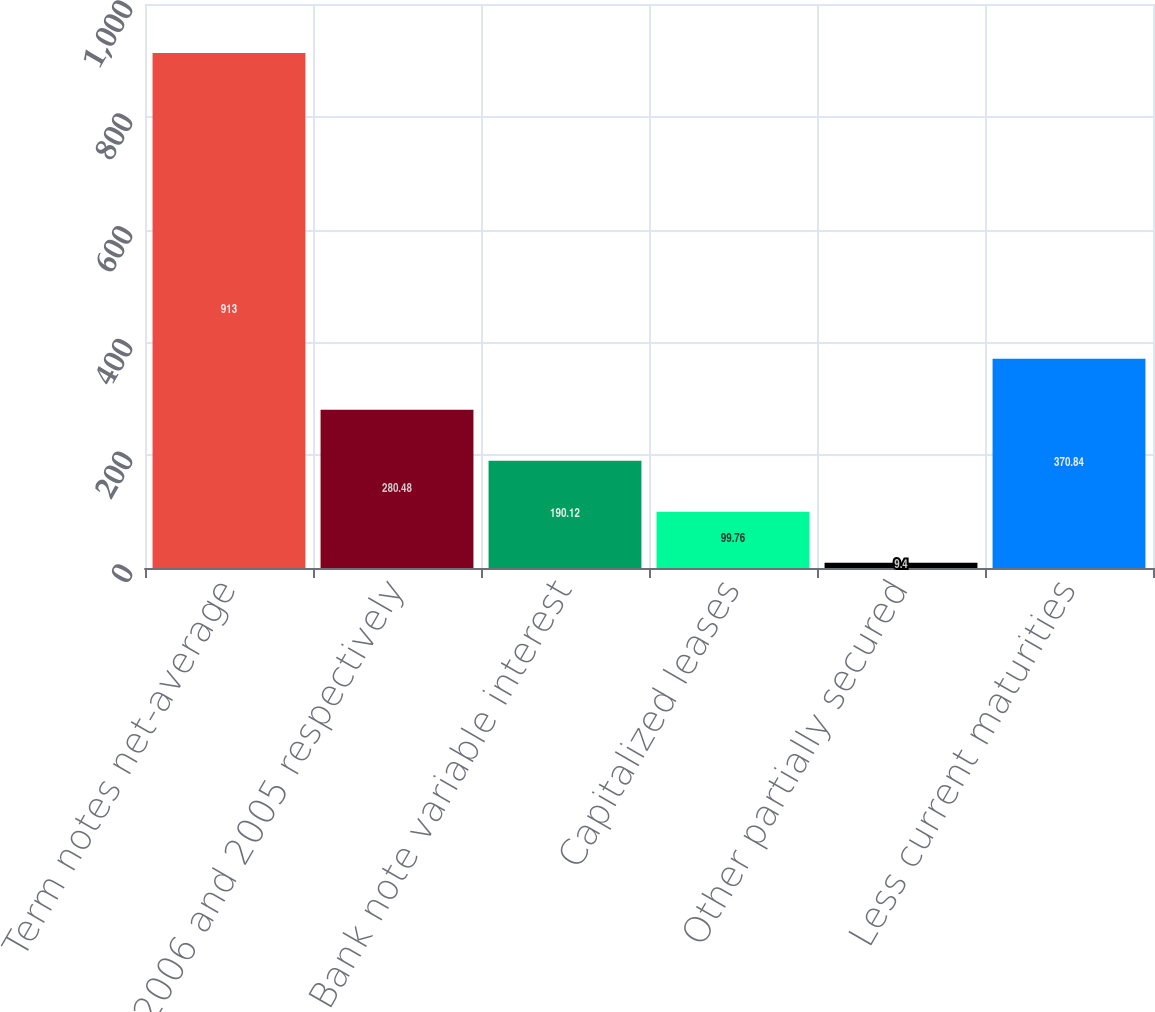Convert chart. <chart><loc_0><loc_0><loc_500><loc_500><bar_chart><fcel>Term notes net-average<fcel>for 2006 and 2005 respectively<fcel>Bank note variable interest<fcel>Capitalized leases<fcel>Other partially secured<fcel>Less current maturities<nl><fcel>913<fcel>280.48<fcel>190.12<fcel>99.76<fcel>9.4<fcel>370.84<nl></chart> 